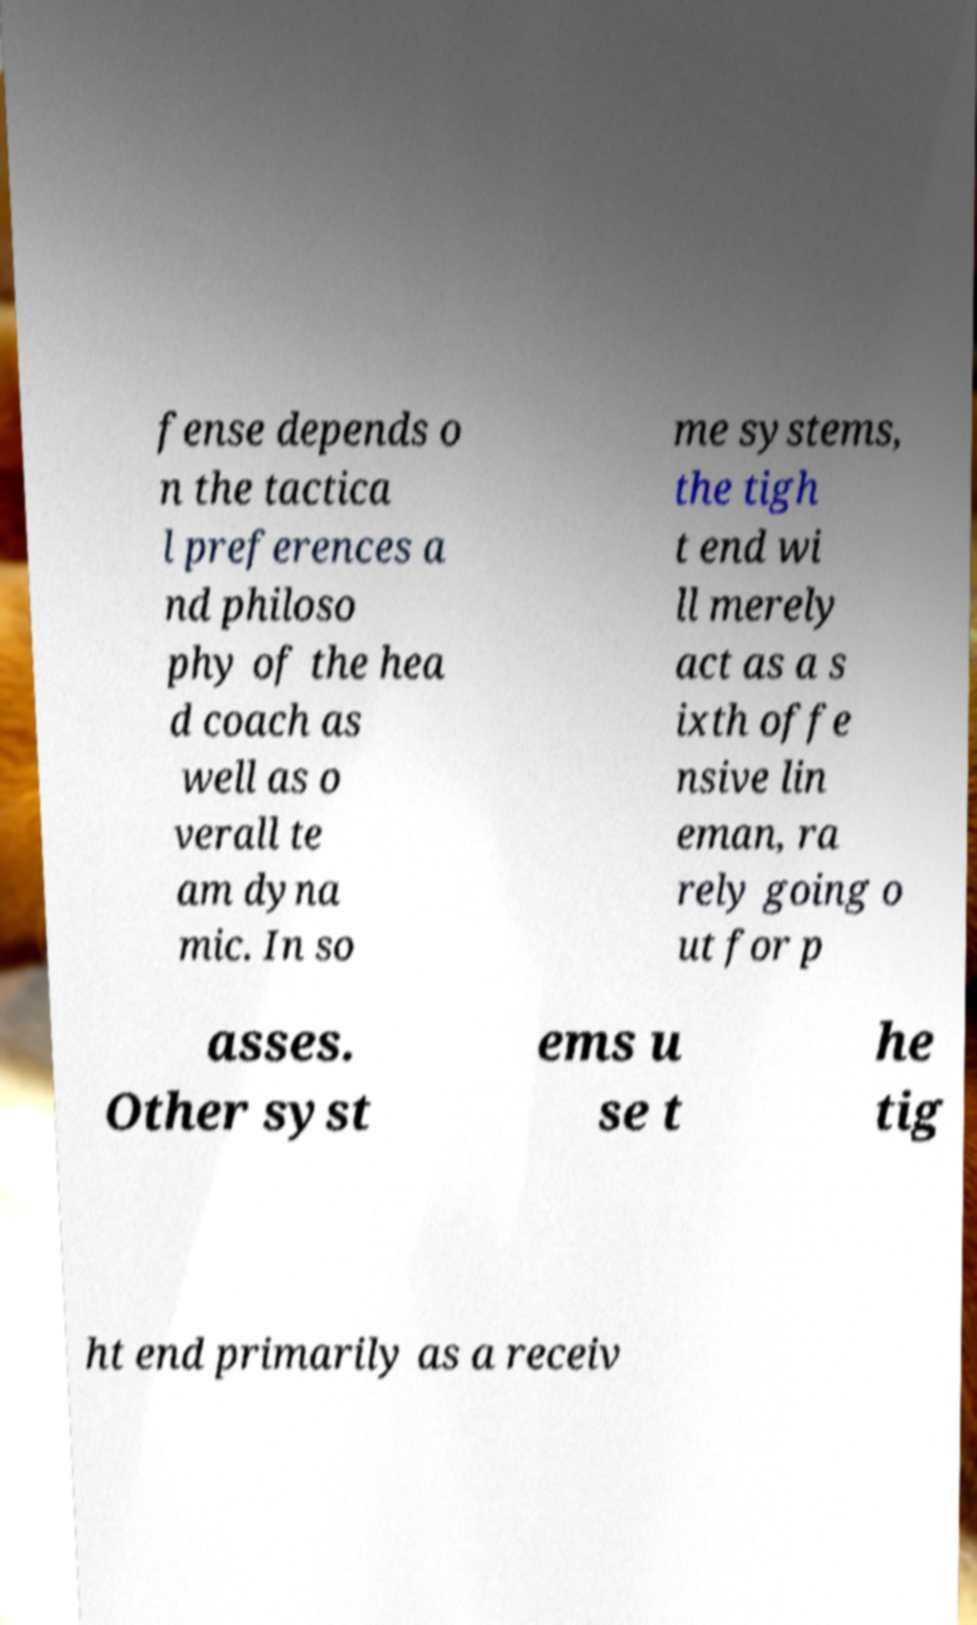Please read and relay the text visible in this image. What does it say? fense depends o n the tactica l preferences a nd philoso phy of the hea d coach as well as o verall te am dyna mic. In so me systems, the tigh t end wi ll merely act as a s ixth offe nsive lin eman, ra rely going o ut for p asses. Other syst ems u se t he tig ht end primarily as a receiv 